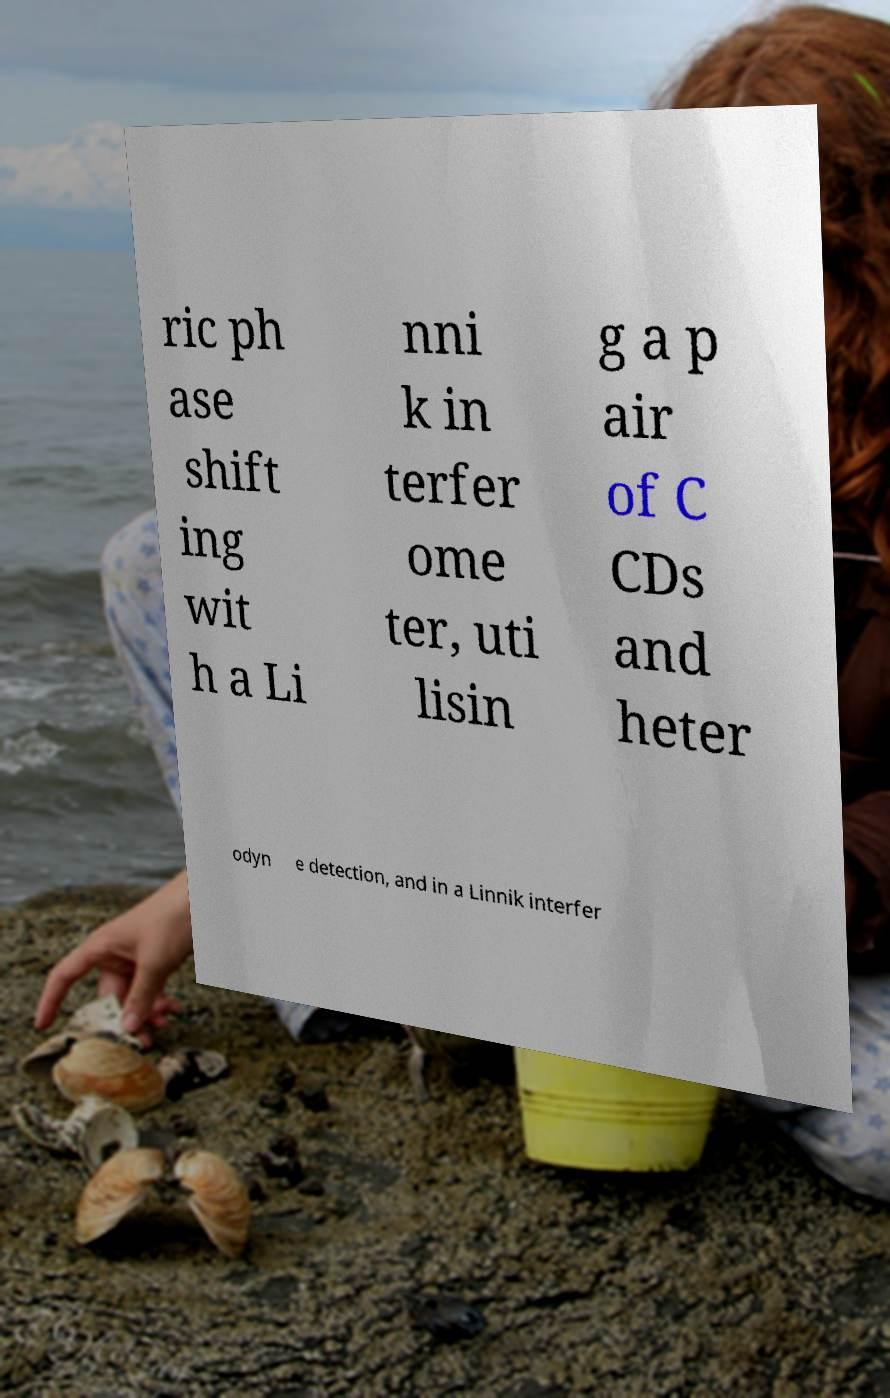There's text embedded in this image that I need extracted. Can you transcribe it verbatim? ric ph ase shift ing wit h a Li nni k in terfer ome ter, uti lisin g a p air of C CDs and heter odyn e detection, and in a Linnik interfer 